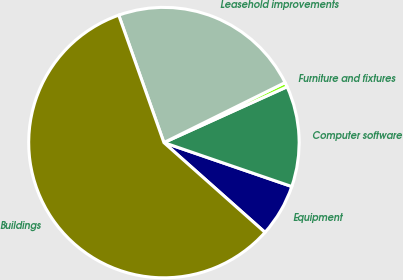Convert chart. <chart><loc_0><loc_0><loc_500><loc_500><pie_chart><fcel>Equipment<fcel>Computer software<fcel>Furniture and fixtures<fcel>Leasehold improvements<fcel>Buildings<nl><fcel>6.29%<fcel>12.04%<fcel>0.55%<fcel>23.1%<fcel>58.02%<nl></chart> 